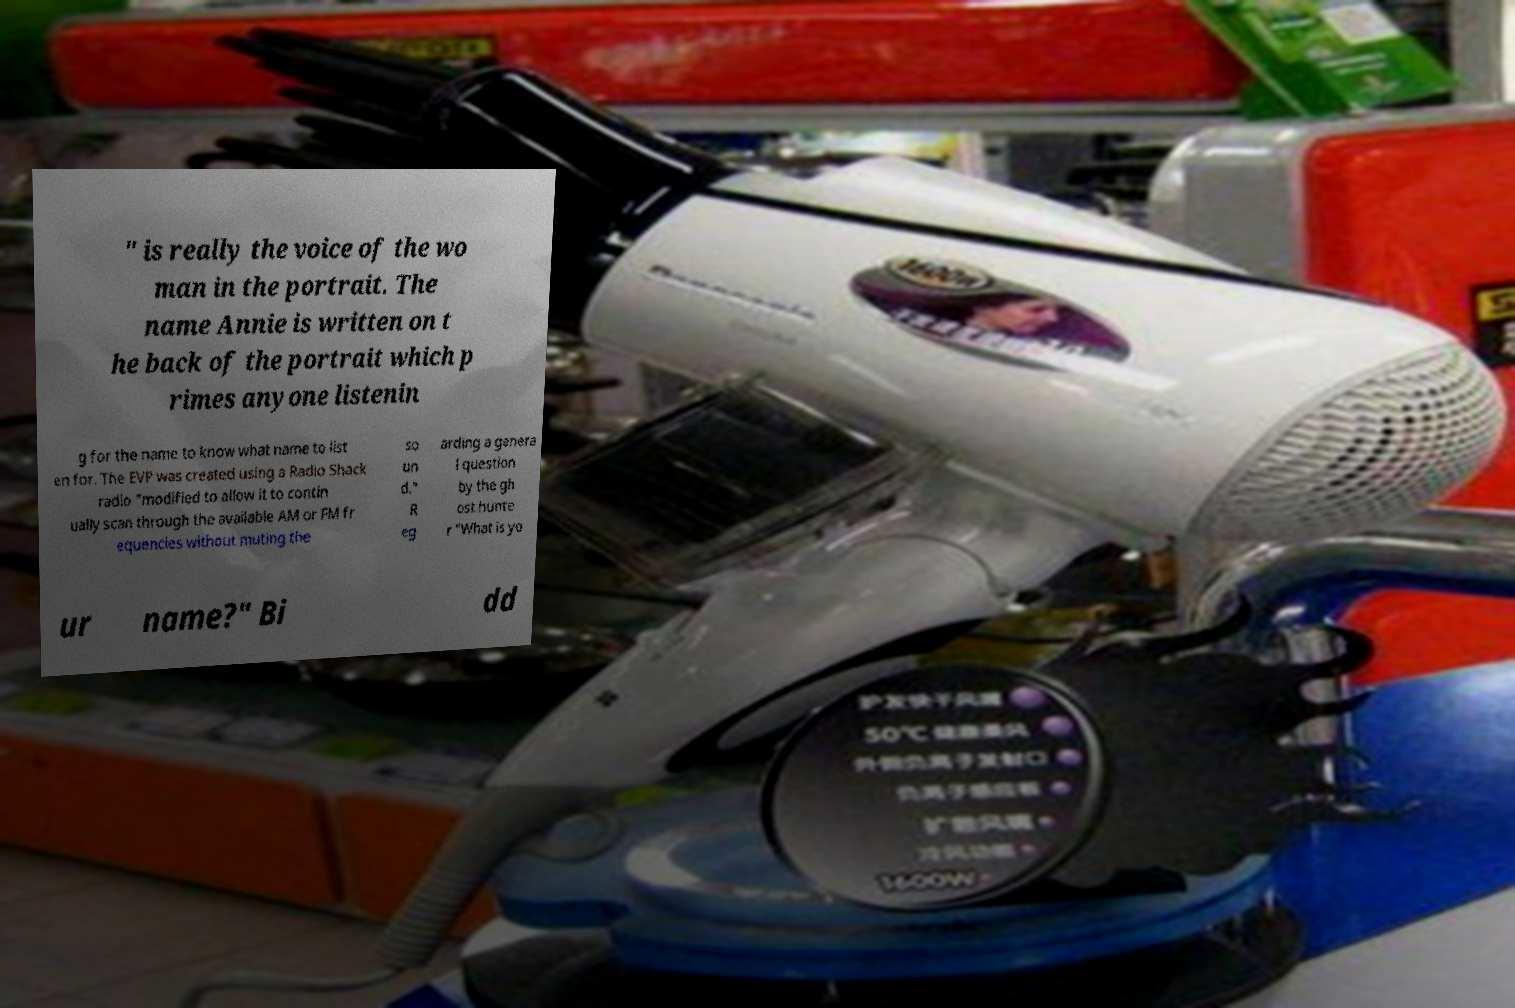Could you extract and type out the text from this image? " is really the voice of the wo man in the portrait. The name Annie is written on t he back of the portrait which p rimes anyone listenin g for the name to know what name to list en for. The EVP was created using a Radio Shack radio "modified to allow it to contin ually scan through the available AM or FM fr equencies without muting the so un d." R eg arding a genera l question by the gh ost hunte r "What is yo ur name?" Bi dd 